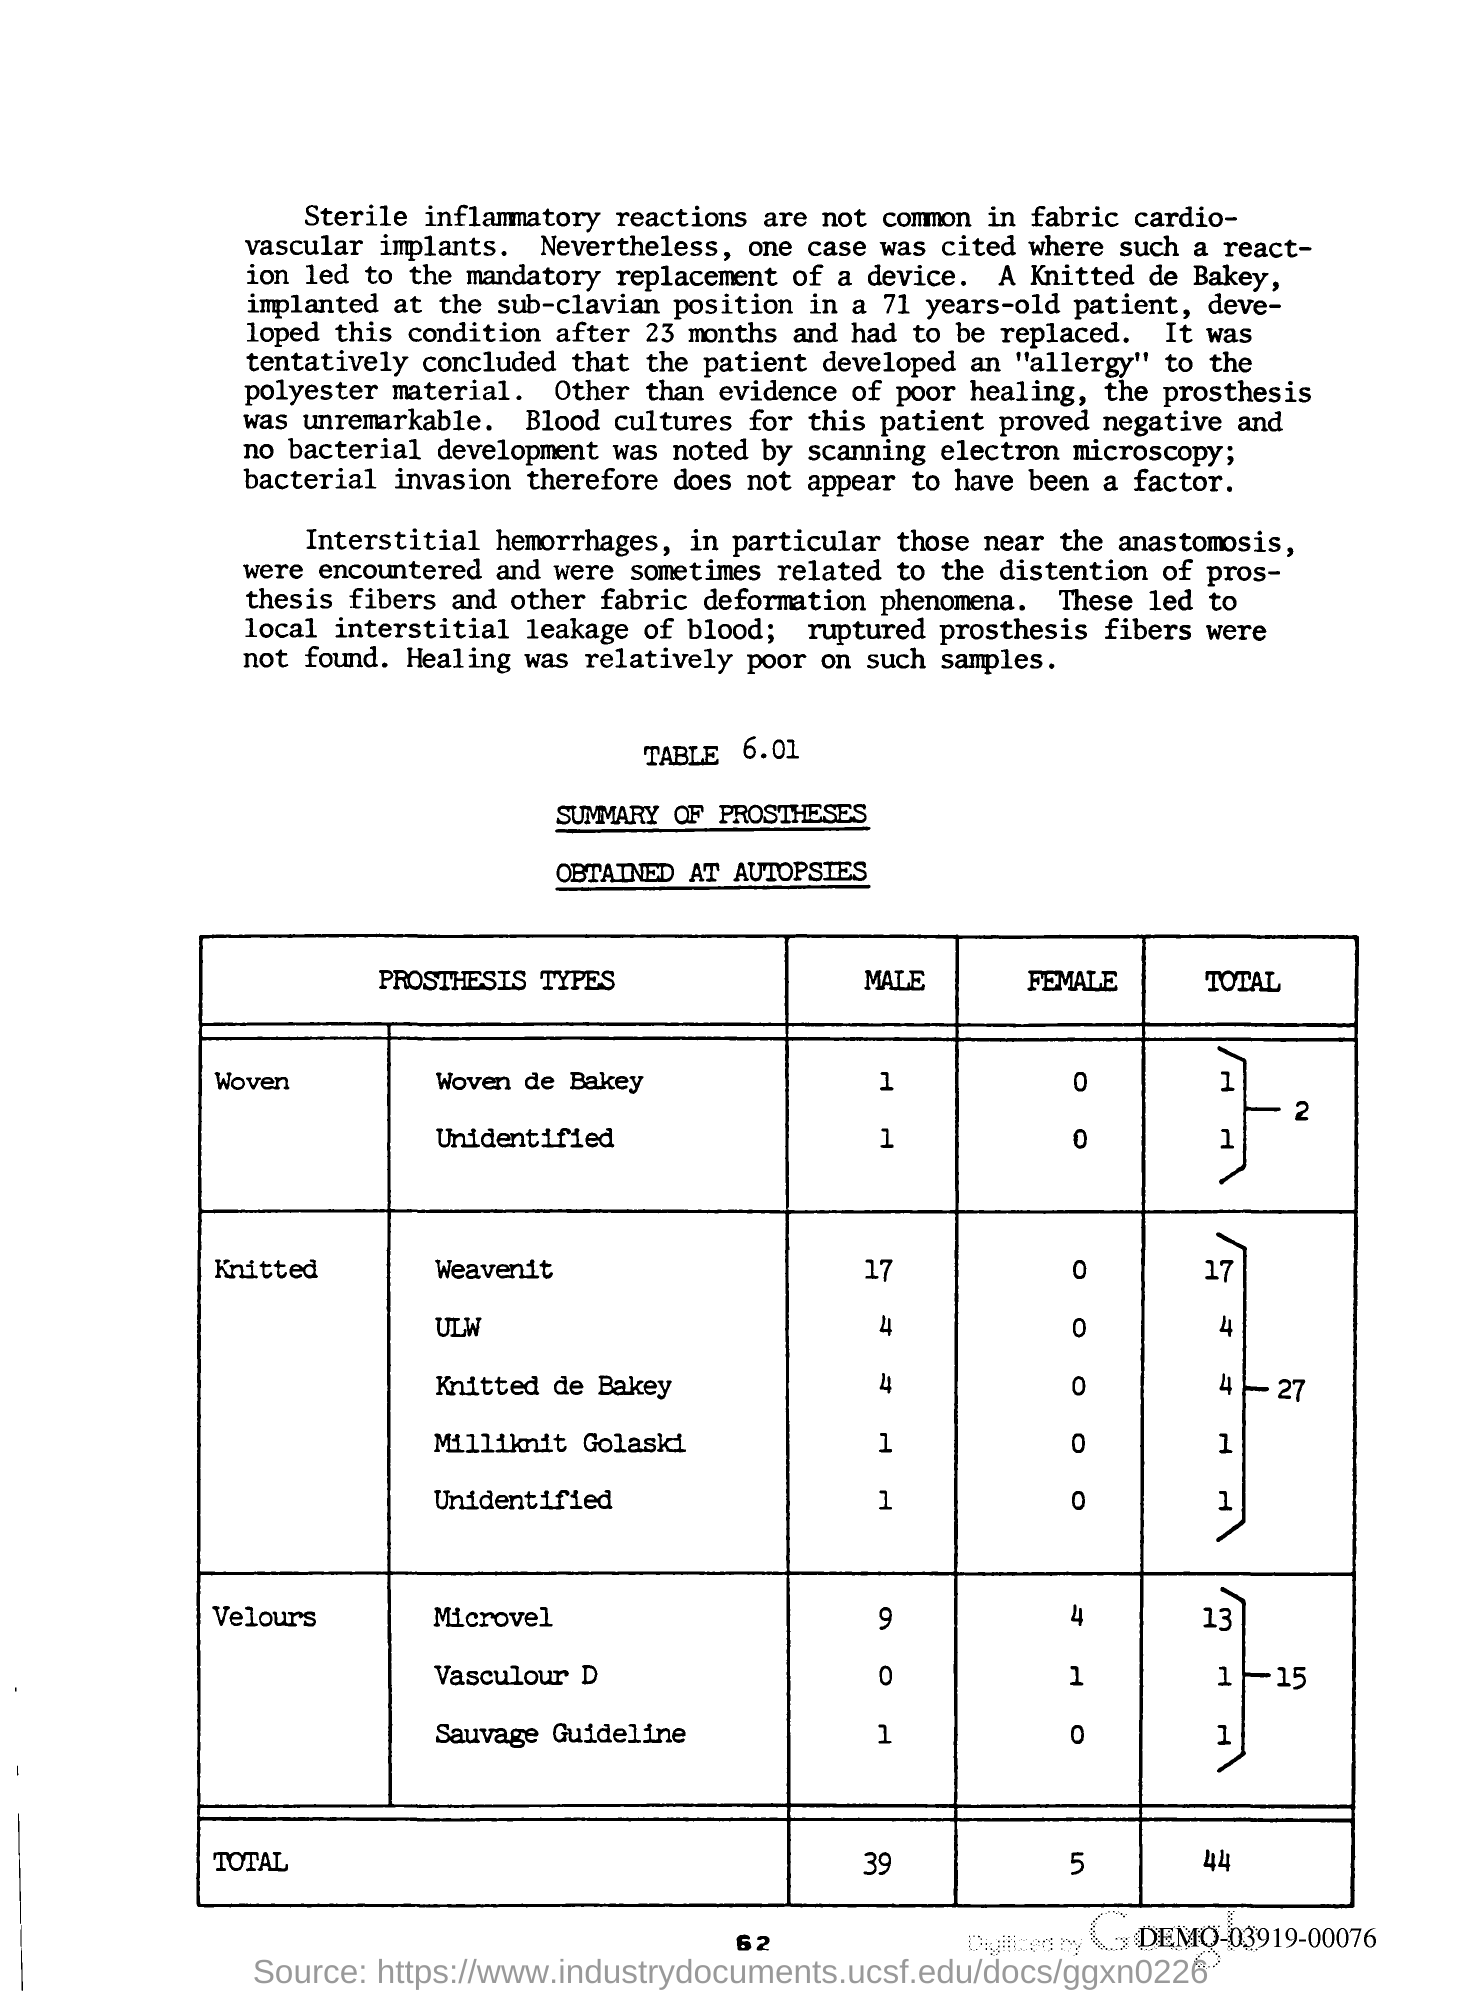Give some essential details in this illustration. The page number is 62. 